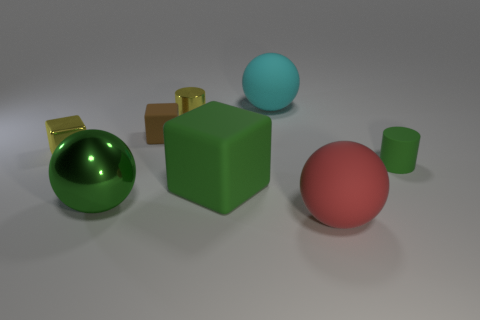How many things are large matte things in front of the metal cylinder or objects in front of the shiny sphere?
Give a very brief answer. 2. There is a cylinder that is on the left side of the rubber sphere in front of the green rubber cube; how many large green matte cubes are behind it?
Ensure brevity in your answer.  0. How big is the green matte thing to the left of the cyan thing?
Ensure brevity in your answer.  Large. How many other brown matte things have the same size as the brown thing?
Provide a succinct answer. 0. There is a green rubber block; is it the same size as the object that is left of the large green shiny object?
Ensure brevity in your answer.  No. What number of objects are either large rubber blocks or green matte cylinders?
Provide a succinct answer. 2. How many other things are the same color as the big shiny thing?
Your answer should be very brief. 2. There is a green rubber thing that is the same size as the brown rubber cube; what is its shape?
Make the answer very short. Cylinder. Are there any other red things that have the same shape as the red object?
Provide a short and direct response. No. How many other objects have the same material as the tiny green thing?
Your answer should be very brief. 4. 